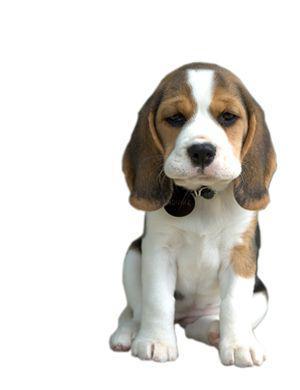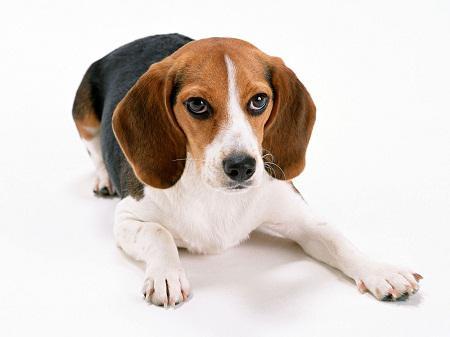The first image is the image on the left, the second image is the image on the right. For the images shown, is this caption "both dogs are sitting with its front legs up." true? Answer yes or no. No. 